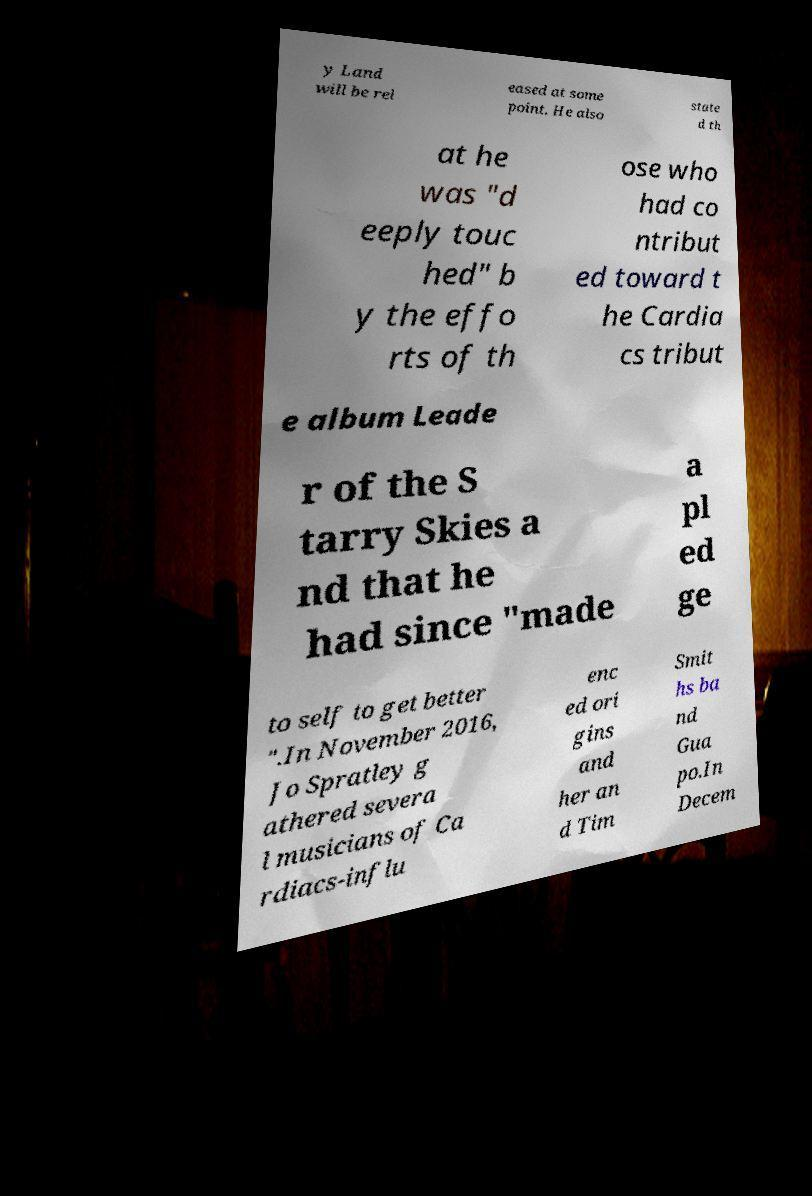I need the written content from this picture converted into text. Can you do that? y Land will be rel eased at some point. He also state d th at he was "d eeply touc hed" b y the effo rts of th ose who had co ntribut ed toward t he Cardia cs tribut e album Leade r of the S tarry Skies a nd that he had since "made a pl ed ge to self to get better ".In November 2016, Jo Spratley g athered severa l musicians of Ca rdiacs-influ enc ed ori gins and her an d Tim Smit hs ba nd Gua po.In Decem 